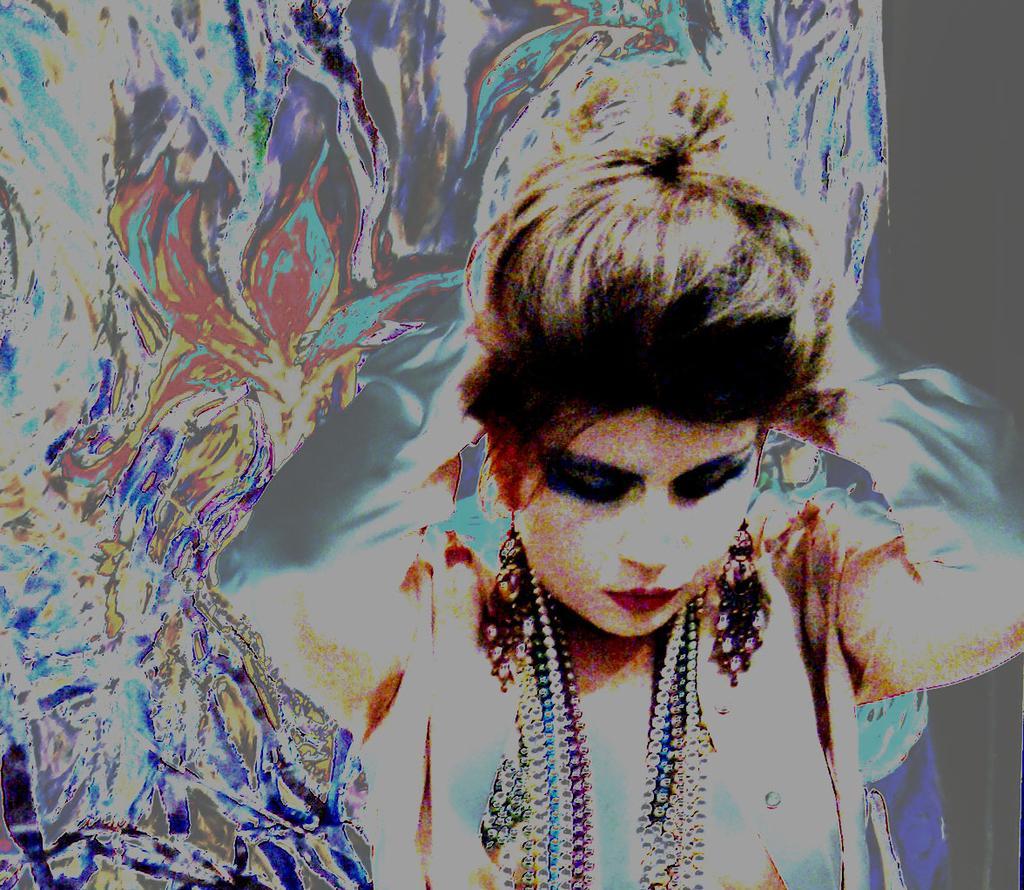Please provide a concise description of this image. Here we can see a graphical image, in this picture we can see a woman in the front. 